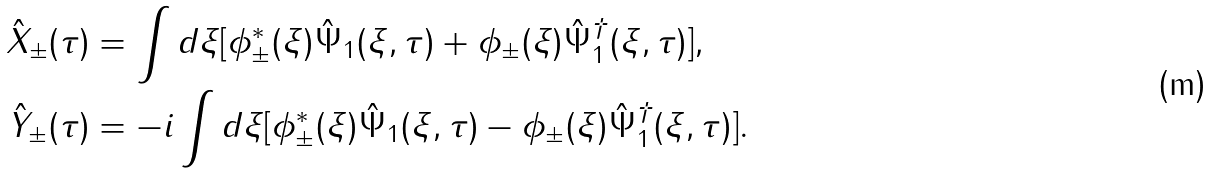<formula> <loc_0><loc_0><loc_500><loc_500>\hat { X } _ { \pm } ( \tau ) & = \int d \xi [ \phi _ { \pm } ^ { \ast } ( \xi ) \hat { \Psi } _ { 1 } ( \xi , \tau ) + \phi _ { \pm } ( \xi ) \hat { \Psi } _ { 1 } ^ { \dagger } ( \xi , \tau ) ] , \\ \hat { Y } _ { \pm } ( \tau ) & = - i \int d \xi [ \phi _ { \pm } ^ { \ast } ( \xi ) \hat { \Psi } _ { 1 } ( \xi , \tau ) - \phi _ { \pm } ( \xi ) \hat { \Psi } _ { 1 } ^ { \dagger } ( \xi , \tau ) ] .</formula> 